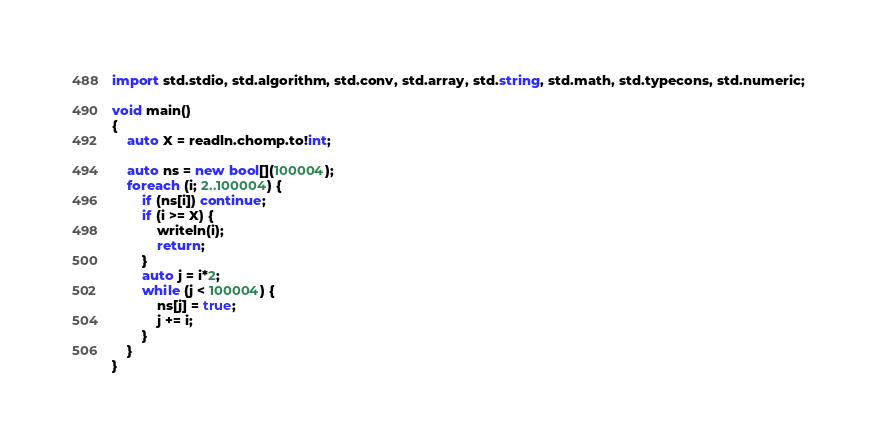<code> <loc_0><loc_0><loc_500><loc_500><_D_>import std.stdio, std.algorithm, std.conv, std.array, std.string, std.math, std.typecons, std.numeric;

void main()
{
    auto X = readln.chomp.to!int;

    auto ns = new bool[](100004);
    foreach (i; 2..100004) {
        if (ns[i]) continue;
        if (i >= X) {
            writeln(i);
            return;
        }
        auto j = i*2;
        while (j < 100004) {
            ns[j] = true;
            j += i;
        }
    }
}</code> 